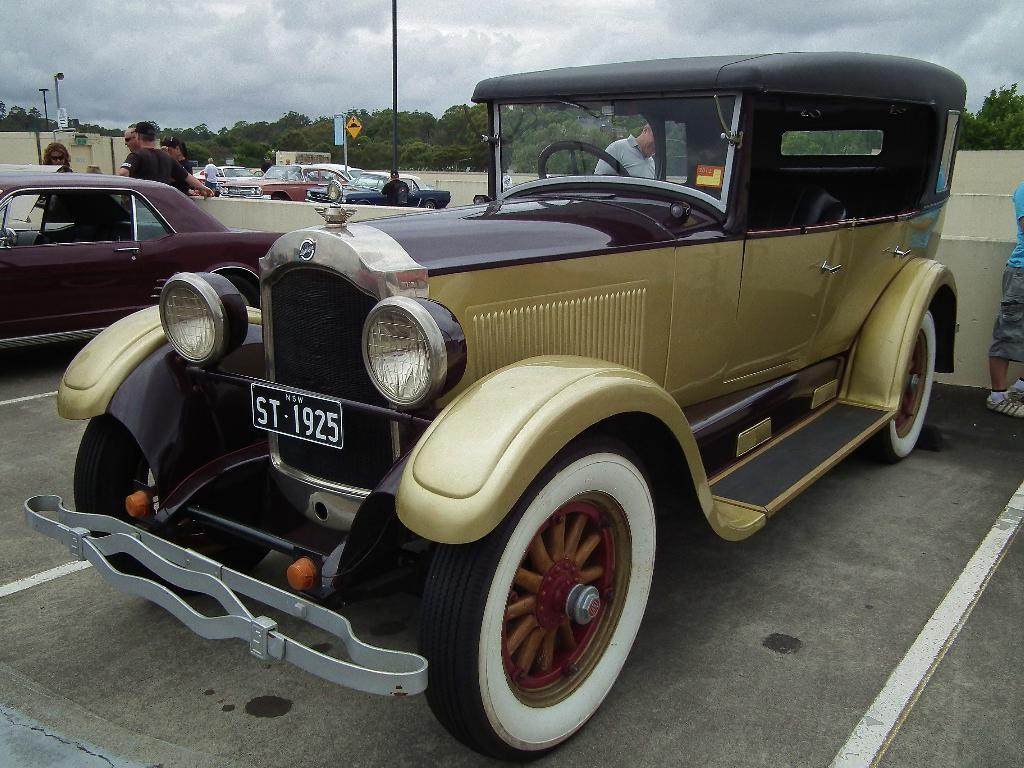What is the main subject in the center of the image? There are cars in the center of the image. Can you describe the people visible in the image? There are people visible in the image. What can be seen in the background of the image? There are trees and poles in the background of the image, as well as the sky. What letter does the car's license plate start with in the image? The provided facts do not mention any specific details about the license plates of the cars in the image, so we cannot determine the starting letter. 